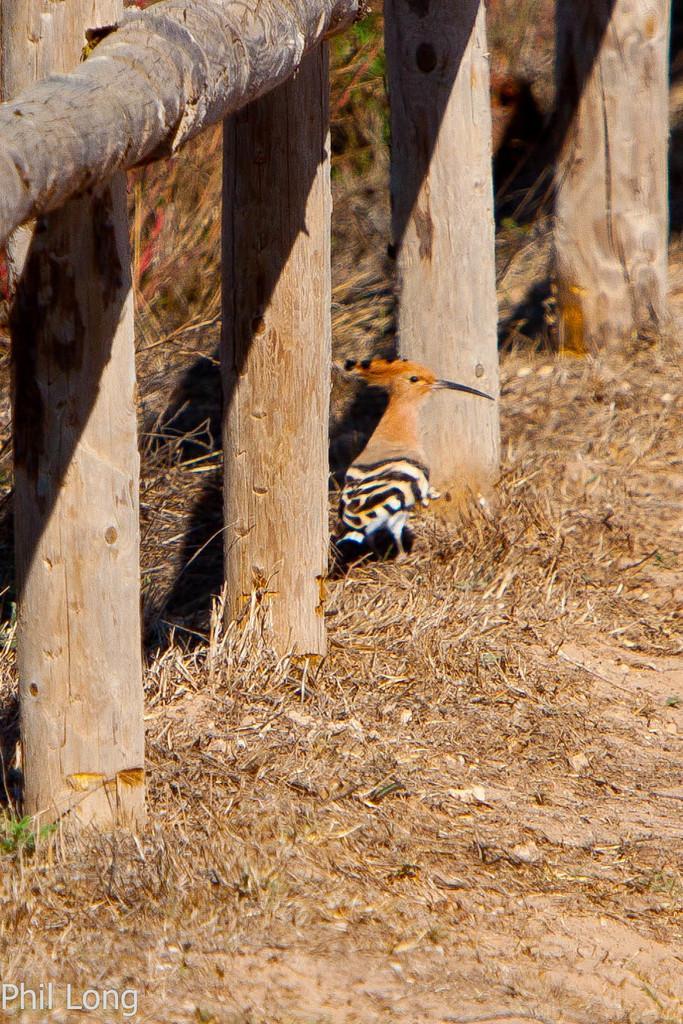How would you summarize this image in a sentence or two? In this picture there is a boundary on the left side of the image and there is a bird in the center of the image. 